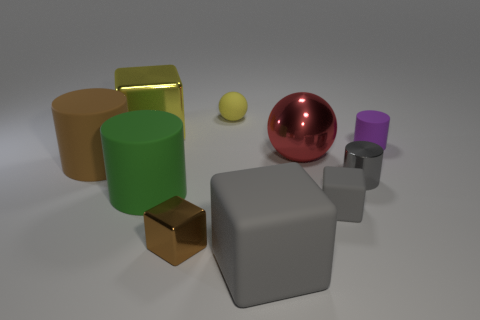Is the number of blue matte balls greater than the number of big green objects?
Offer a terse response. No. There is a big cube that is left of the tiny yellow sphere; does it have the same color as the object that is behind the large shiny block?
Offer a terse response. Yes. There is a yellow thing left of the yellow matte sphere; are there any big blocks that are in front of it?
Provide a succinct answer. Yes. Is the number of matte objects that are in front of the small gray shiny thing less than the number of rubber objects behind the tiny gray cube?
Make the answer very short. Yes. Is the large block behind the large brown cylinder made of the same material as the sphere behind the purple cylinder?
Give a very brief answer. No. How many small objects are yellow rubber spheres or green matte cylinders?
Provide a succinct answer. 1. There is a gray object that is made of the same material as the large gray cube; what shape is it?
Make the answer very short. Cube. Is the number of large green matte cylinders behind the brown rubber thing less than the number of small gray metal things?
Provide a short and direct response. Yes. Is the big gray object the same shape as the yellow shiny thing?
Provide a short and direct response. Yes. How many metallic objects are either green things or cubes?
Keep it short and to the point. 2. 